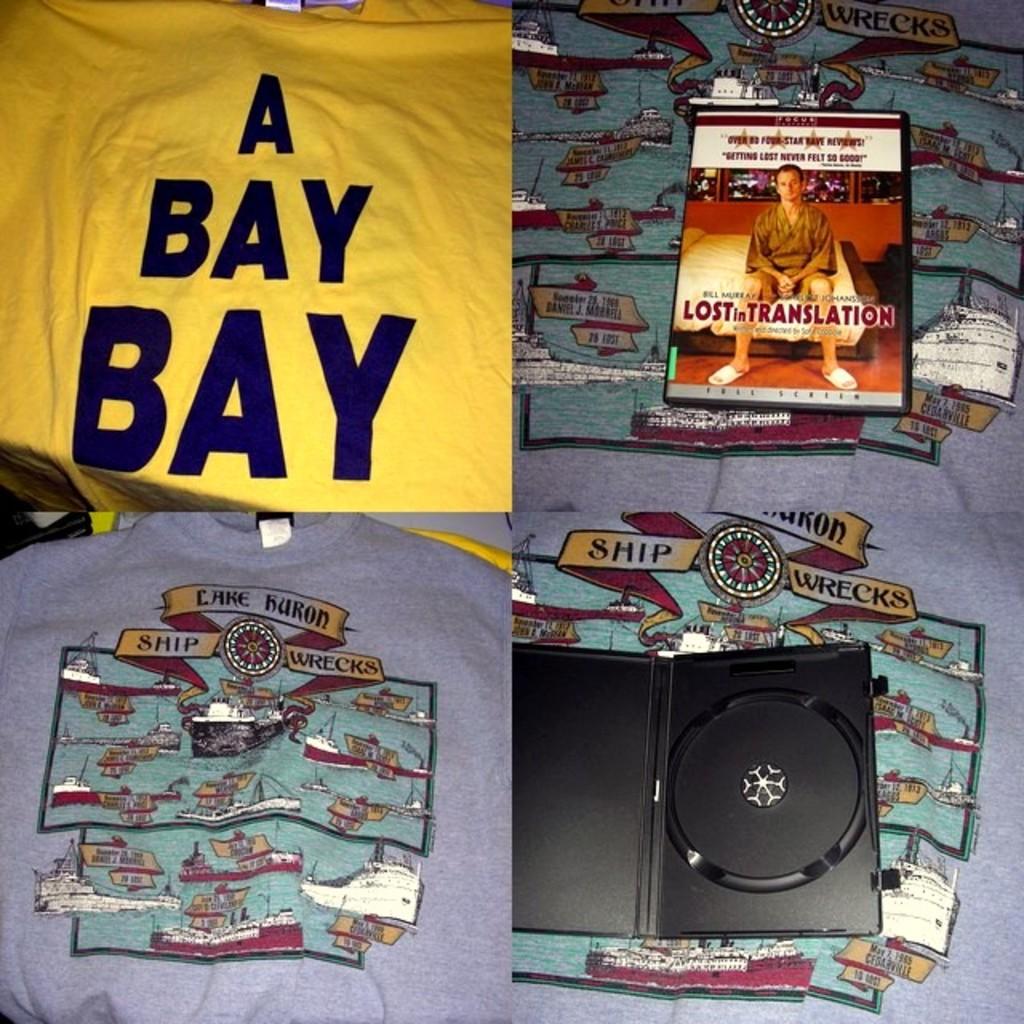What movie is listed?
Your response must be concise. Lost in translation. What is written on the yellow shirt?
Make the answer very short. A bay bay. 